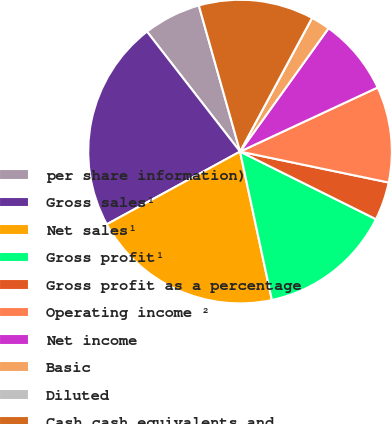<chart> <loc_0><loc_0><loc_500><loc_500><pie_chart><fcel>per share information)<fcel>Gross sales¹<fcel>Net sales¹<fcel>Gross profit¹<fcel>Gross profit as a percentage<fcel>Operating income ²<fcel>Net income<fcel>Basic<fcel>Diluted<fcel>Cash cash equivalents and<nl><fcel>6.12%<fcel>22.45%<fcel>20.41%<fcel>14.29%<fcel>4.08%<fcel>10.2%<fcel>8.16%<fcel>2.04%<fcel>0.0%<fcel>12.24%<nl></chart> 